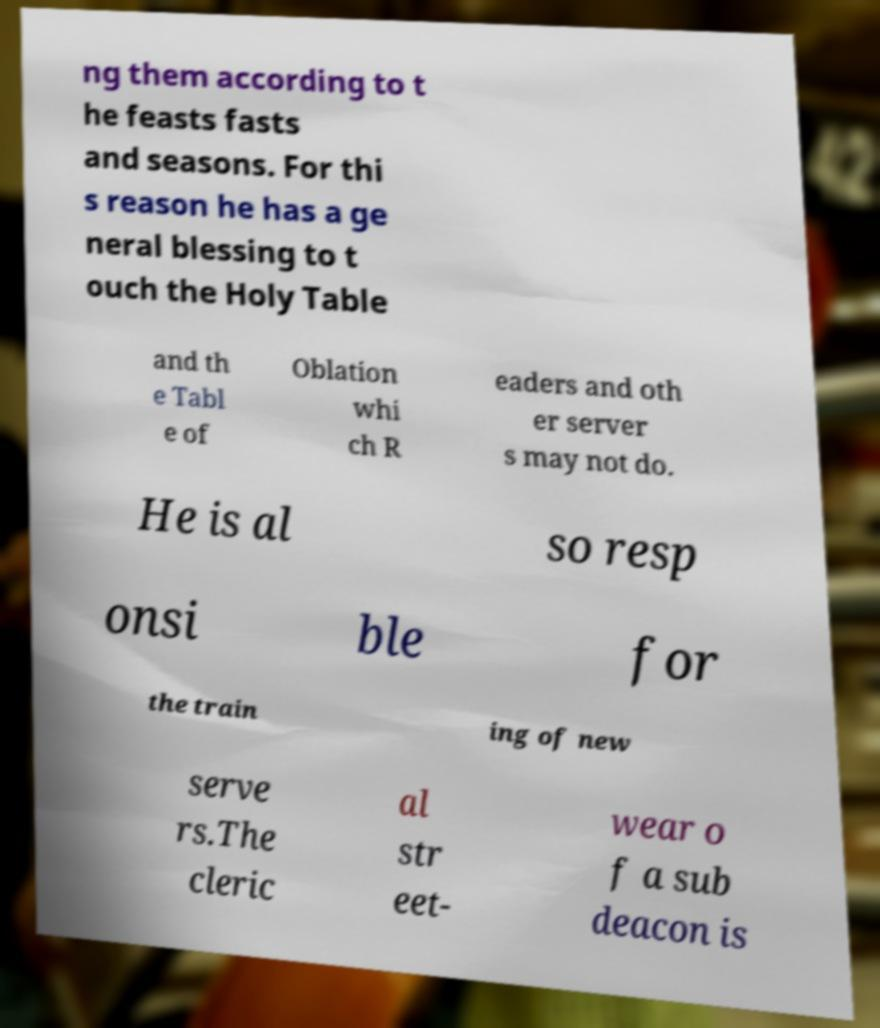Could you extract and type out the text from this image? ng them according to t he feasts fasts and seasons. For thi s reason he has a ge neral blessing to t ouch the Holy Table and th e Tabl e of Oblation whi ch R eaders and oth er server s may not do. He is al so resp onsi ble for the train ing of new serve rs.The cleric al str eet- wear o f a sub deacon is 